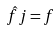<formula> <loc_0><loc_0><loc_500><loc_500>\hat { f } j = f</formula> 